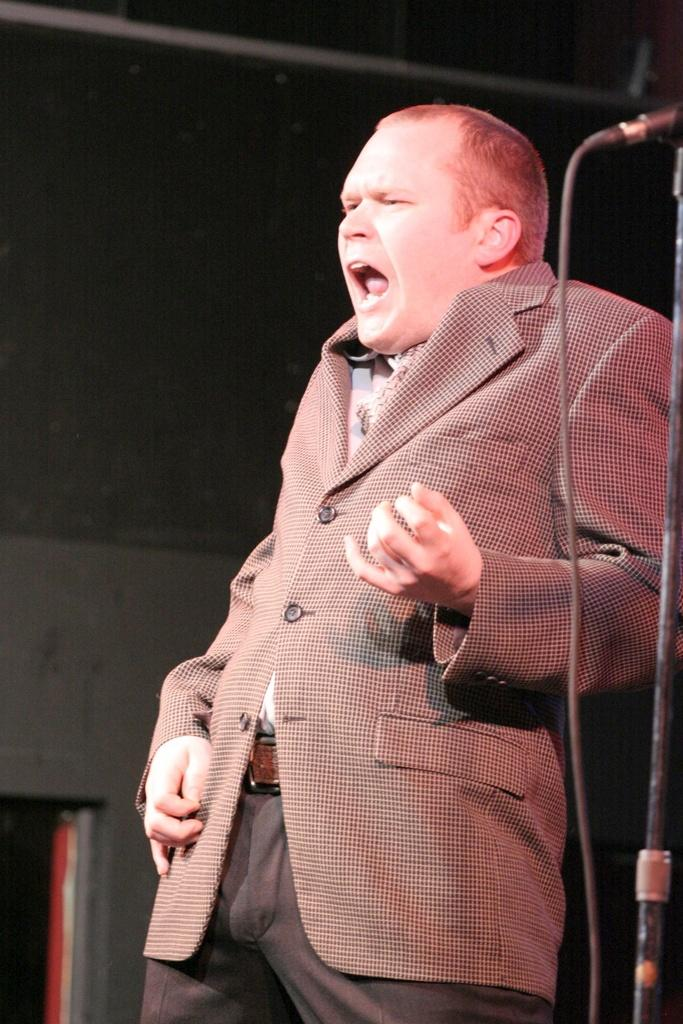What is the main subject of the image? There is a man standing in the image. What can be seen in the background of the image? There is a wall in the background of the image. What object is located on the right side of the image? There is a microphone on the right side of the image. What type of collar is the man wearing in the image? There is no collar visible in the image, as the man is not wearing a shirt or any clothing that would have a collar. What type of jeans is the man wearing in the image? There is no information about the man's pants in the image, so it cannot be determined if he is wearing jeans or any other type of clothing. 